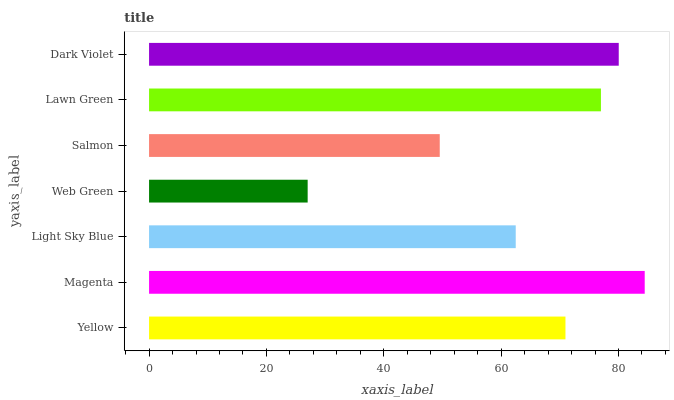Is Web Green the minimum?
Answer yes or no. Yes. Is Magenta the maximum?
Answer yes or no. Yes. Is Light Sky Blue the minimum?
Answer yes or no. No. Is Light Sky Blue the maximum?
Answer yes or no. No. Is Magenta greater than Light Sky Blue?
Answer yes or no. Yes. Is Light Sky Blue less than Magenta?
Answer yes or no. Yes. Is Light Sky Blue greater than Magenta?
Answer yes or no. No. Is Magenta less than Light Sky Blue?
Answer yes or no. No. Is Yellow the high median?
Answer yes or no. Yes. Is Yellow the low median?
Answer yes or no. Yes. Is Salmon the high median?
Answer yes or no. No. Is Dark Violet the low median?
Answer yes or no. No. 